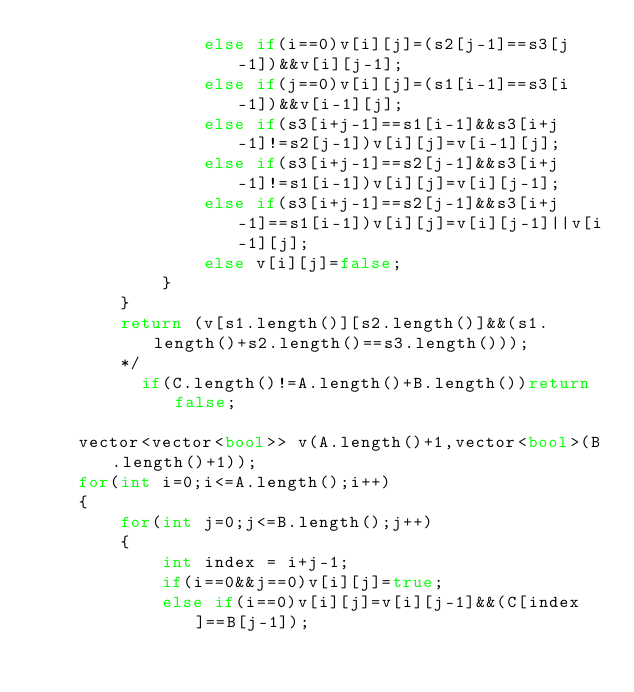<code> <loc_0><loc_0><loc_500><loc_500><_C++_>                else if(i==0)v[i][j]=(s2[j-1]==s3[j-1])&&v[i][j-1];
                else if(j==0)v[i][j]=(s1[i-1]==s3[i-1])&&v[i-1][j];
                else if(s3[i+j-1]==s1[i-1]&&s3[i+j-1]!=s2[j-1])v[i][j]=v[i-1][j];
                else if(s3[i+j-1]==s2[j-1]&&s3[i+j-1]!=s1[i-1])v[i][j]=v[i][j-1];
                else if(s3[i+j-1]==s2[j-1]&&s3[i+j-1]==s1[i-1])v[i][j]=v[i][j-1]||v[i-1][j];
                else v[i][j]=false;
            }
        }
        return (v[s1.length()][s2.length()]&&(s1.length()+s2.length()==s3.length()));
        */
          if(C.length()!=A.length()+B.length())return false;
    
    vector<vector<bool>> v(A.length()+1,vector<bool>(B.length()+1));
    for(int i=0;i<=A.length();i++)
    {
        for(int j=0;j<=B.length();j++)
        {
            int index = i+j-1;
            if(i==0&&j==0)v[i][j]=true;
            else if(i==0)v[i][j]=v[i][j-1]&&(C[index]==B[j-1]);</code> 